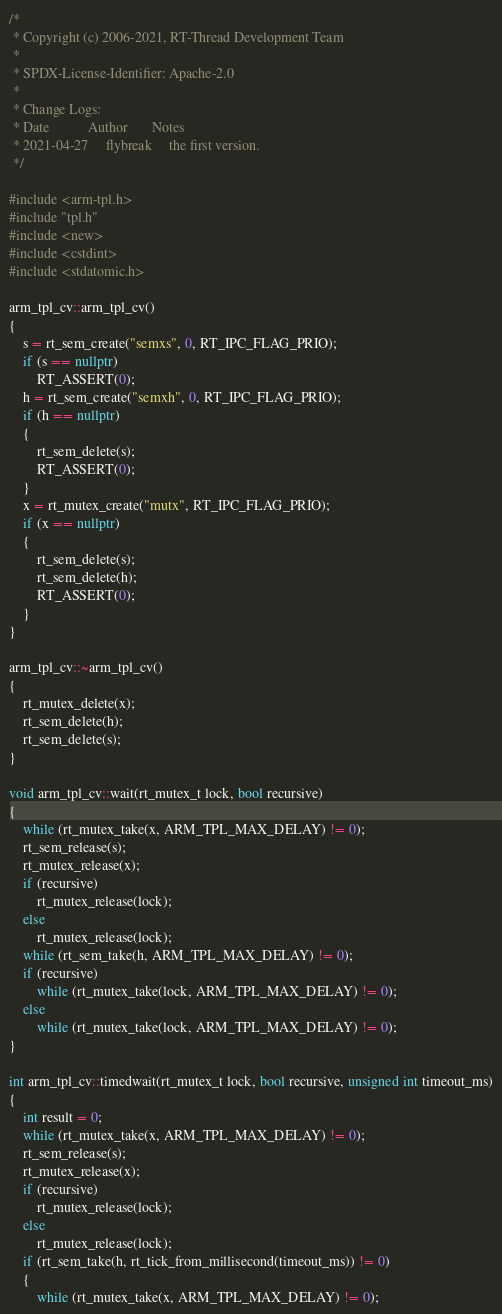<code> <loc_0><loc_0><loc_500><loc_500><_C++_>/*
 * Copyright (c) 2006-2021, RT-Thread Development Team
 *
 * SPDX-License-Identifier: Apache-2.0
 *
 * Change Logs:
 * Date           Author       Notes
 * 2021-04-27     flybreak     the first version.
 */

#include <arm-tpl.h>
#include "tpl.h"
#include <new>
#include <cstdint>
#include <stdatomic.h>

arm_tpl_cv::arm_tpl_cv()
{
    s = rt_sem_create("semxs", 0, RT_IPC_FLAG_PRIO);
    if (s == nullptr)
        RT_ASSERT(0);
    h = rt_sem_create("semxh", 0, RT_IPC_FLAG_PRIO);
    if (h == nullptr)
    {
        rt_sem_delete(s);
        RT_ASSERT(0);
    }
    x = rt_mutex_create("mutx", RT_IPC_FLAG_PRIO);
    if (x == nullptr)
    {
        rt_sem_delete(s);
        rt_sem_delete(h);
        RT_ASSERT(0);
    }
}

arm_tpl_cv::~arm_tpl_cv()
{
    rt_mutex_delete(x);
    rt_sem_delete(h);
    rt_sem_delete(s);
}

void arm_tpl_cv::wait(rt_mutex_t lock, bool recursive)
{
    while (rt_mutex_take(x, ARM_TPL_MAX_DELAY) != 0);
    rt_sem_release(s);
    rt_mutex_release(x);
    if (recursive)
        rt_mutex_release(lock);
    else
        rt_mutex_release(lock);
    while (rt_sem_take(h, ARM_TPL_MAX_DELAY) != 0);
    if (recursive)
        while (rt_mutex_take(lock, ARM_TPL_MAX_DELAY) != 0);
    else
        while (rt_mutex_take(lock, ARM_TPL_MAX_DELAY) != 0);
}

int arm_tpl_cv::timedwait(rt_mutex_t lock, bool recursive, unsigned int timeout_ms)
{
    int result = 0;
    while (rt_mutex_take(x, ARM_TPL_MAX_DELAY) != 0);
    rt_sem_release(s);
    rt_mutex_release(x);
    if (recursive)
        rt_mutex_release(lock);
    else
        rt_mutex_release(lock);
    if (rt_sem_take(h, rt_tick_from_millisecond(timeout_ms)) != 0)
    {
        while (rt_mutex_take(x, ARM_TPL_MAX_DELAY) != 0);</code> 